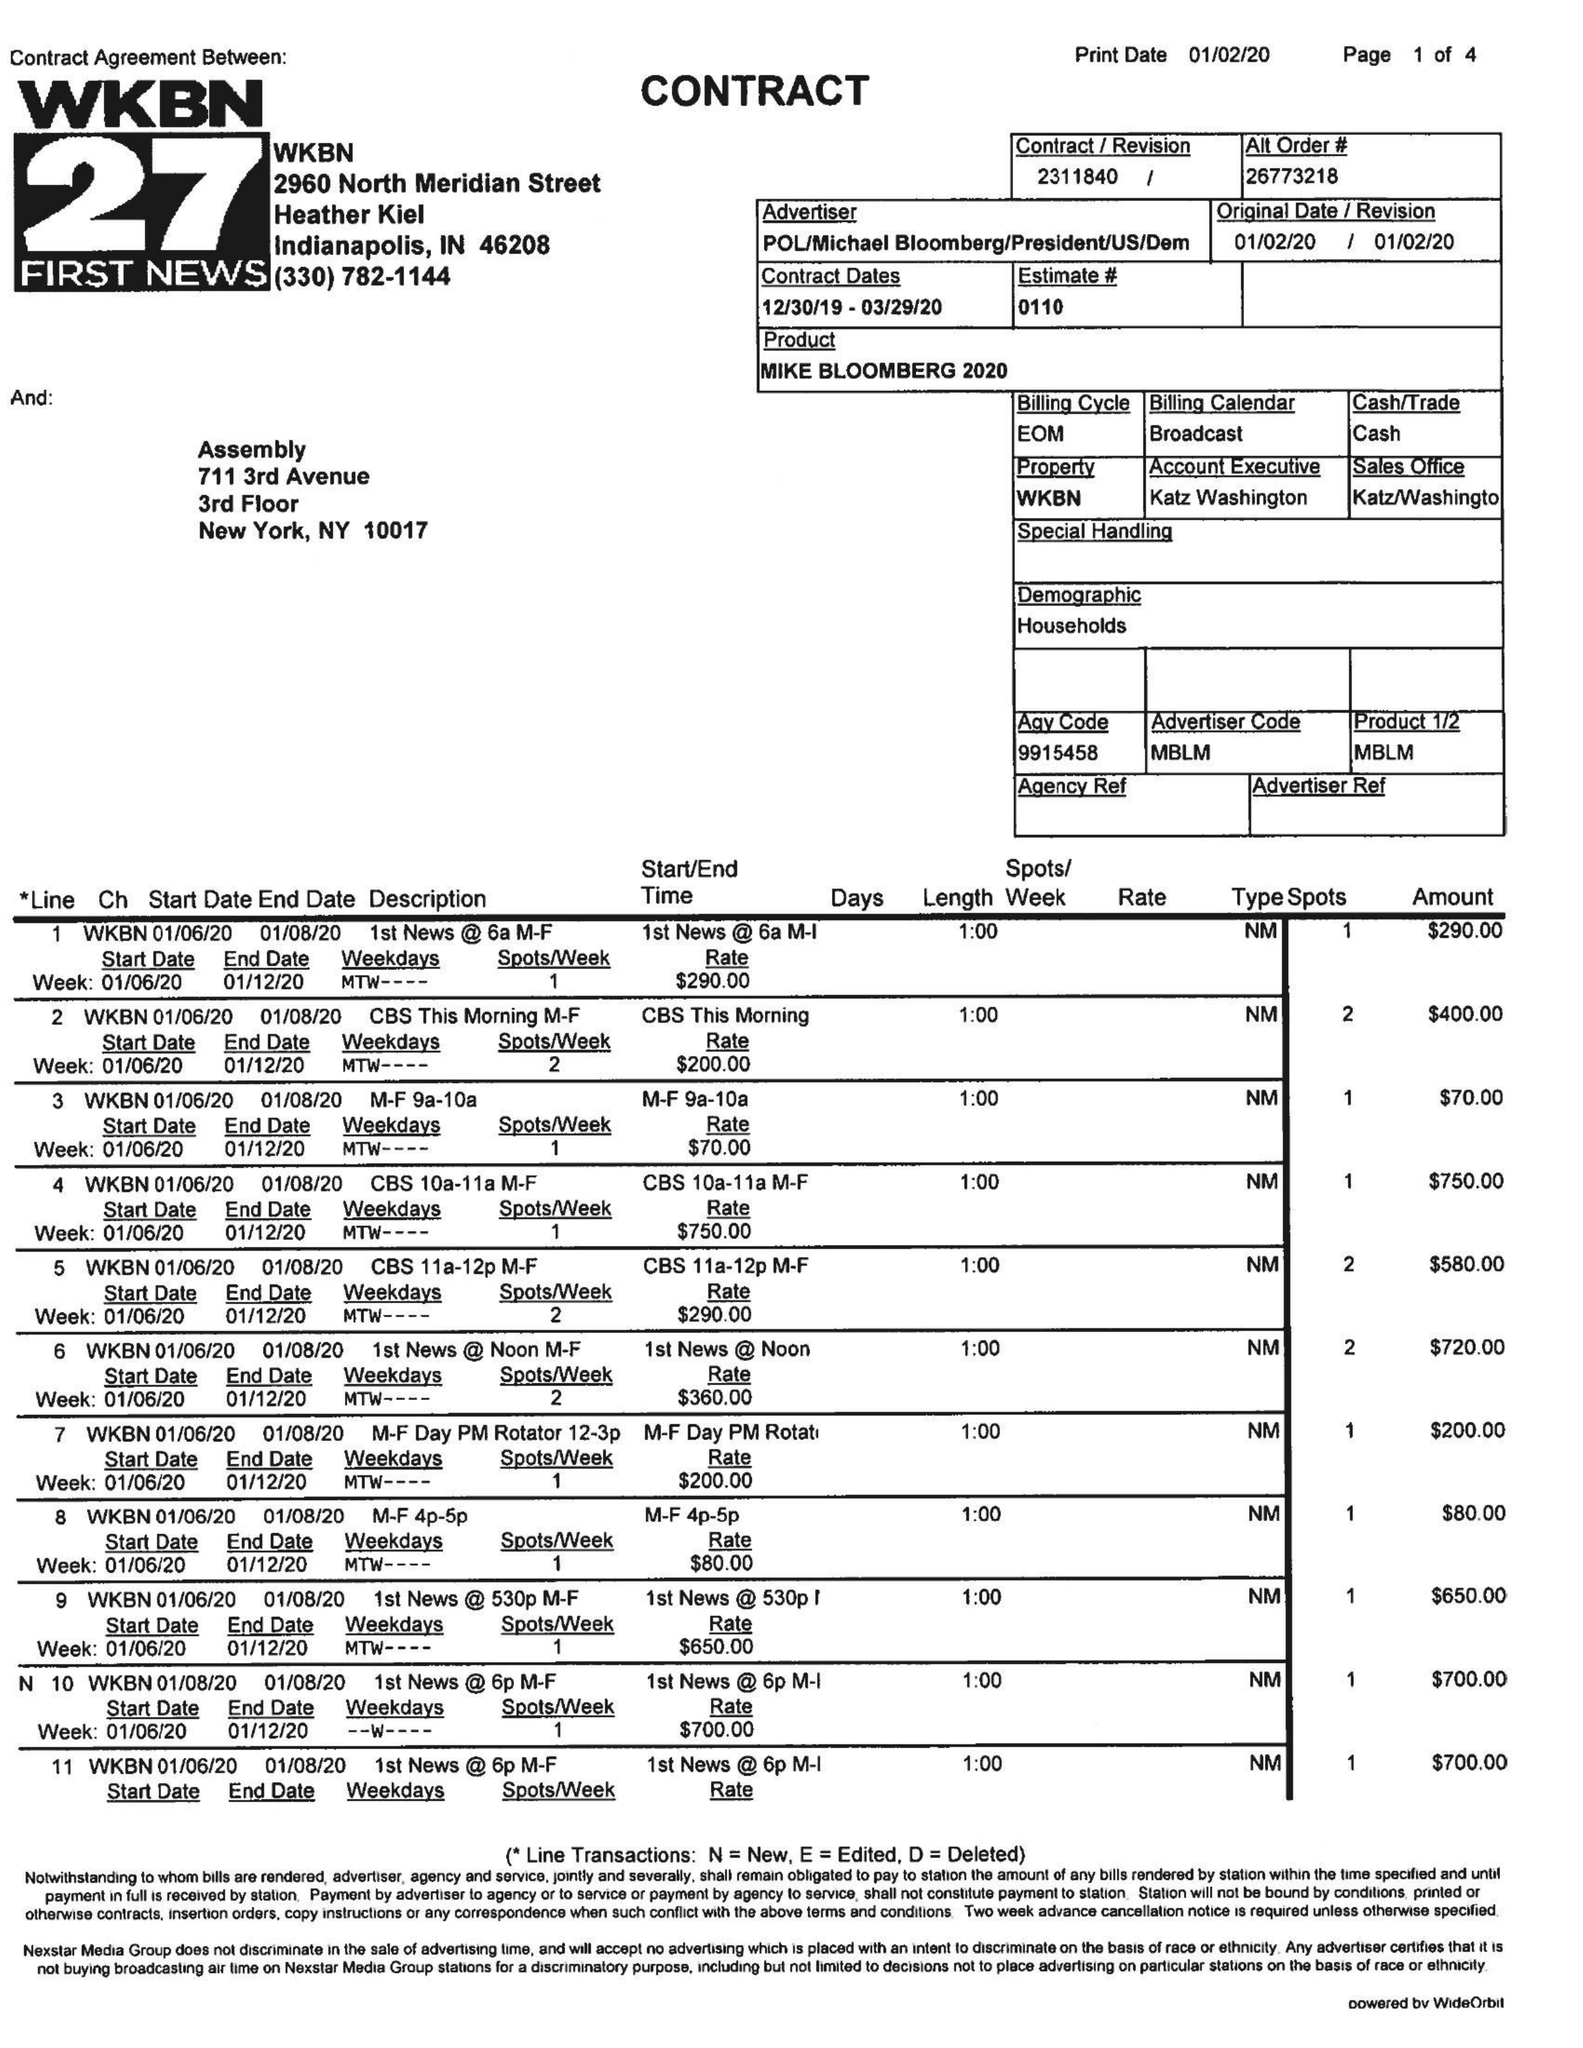What is the value for the flight_to?
Answer the question using a single word or phrase. 03/29/20 